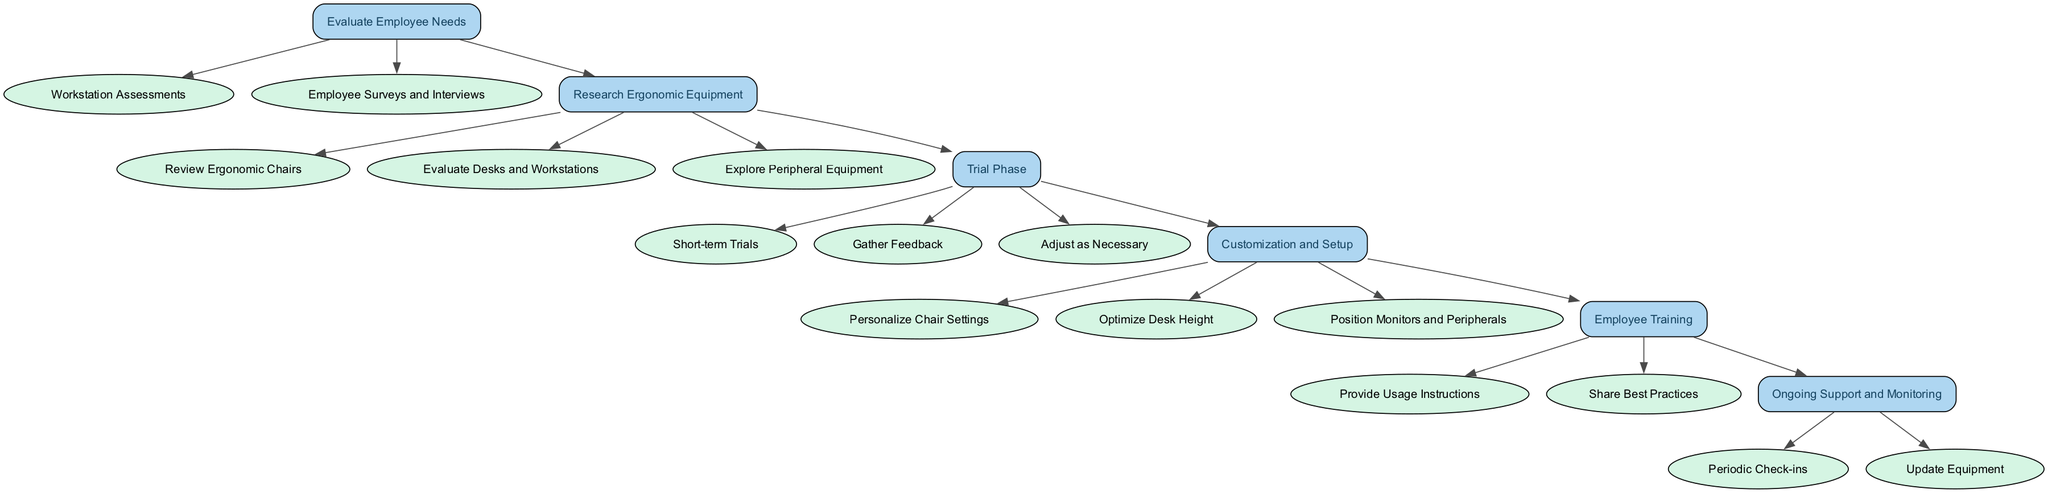What is the first step in the diagram? The first step listed in the diagram is "Evaluate Employee Needs." This is identified at the top of the flowchart as the starting point for selecting ergonomic equipment.
Answer: Evaluate Employee Needs How many substeps are there under "Research Ergonomic Equipment"? There are three substeps under "Research Ergonomic Equipment," which are: "Review Ergonomic Chairs," "Evaluate Desks and Workstations," and "Explore Peripheral Equipment."
Answer: 3 What follows the "Trial Phase" step? After the "Trial Phase," the next step in the diagram is "Customization and Setup." This indicates that customization comes after testing the ergonomic solutions.
Answer: Customization and Setup Which step involves gathering employee feedback? "Trial Phase" is the step that involves gathering employee feedback as one of its substeps, specifically through "Gather Feedback."
Answer: Trial Phase What are the two main activities in the "Employee Training" step? The two main activities in the "Employee Training" step are: "Provide Usage Instructions" and "Share Best Practices." These activities focus on educating employees on ergonomic equipment.
Answer: Provide Usage Instructions and Share Best Practices How does "Ongoing Support and Monitoring" relate to earlier steps? "Ongoing Support and Monitoring" relates to all earlier steps by ensuring that once ergonomic equipment is implemented, there is ongoing assessment and support to maintain ergonomic benefits. It reinforces the previous steps' outcomes.
Answer: It maintains ergonomic benefits from earlier steps Which substep under "Customization and Setup" ensures proper monitor positioning? The substep that specifically focuses on the positioning of monitors is "Position Monitors and Peripherals." This task is crucial for minimizing strain and promoting neutral postures.
Answer: Position Monitors and Peripherals What is the main purpose of conducting workstation assessments? The main purpose of conducting workstation assessments is to observe and document how employees interact with their current workstations, which helps identify their ergonomic needs.
Answer: To document employee interaction Which two steps directly engage employees in the process? "Trial Phase" and "Employee Training" directly engage employees. The Trial Phase involves testing equipment with employees, while Employee Training educates them on proper usage.
Answer: Trial Phase and Employee Training 